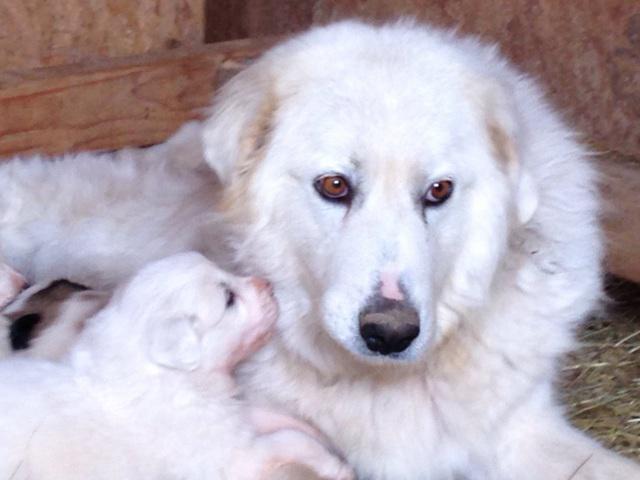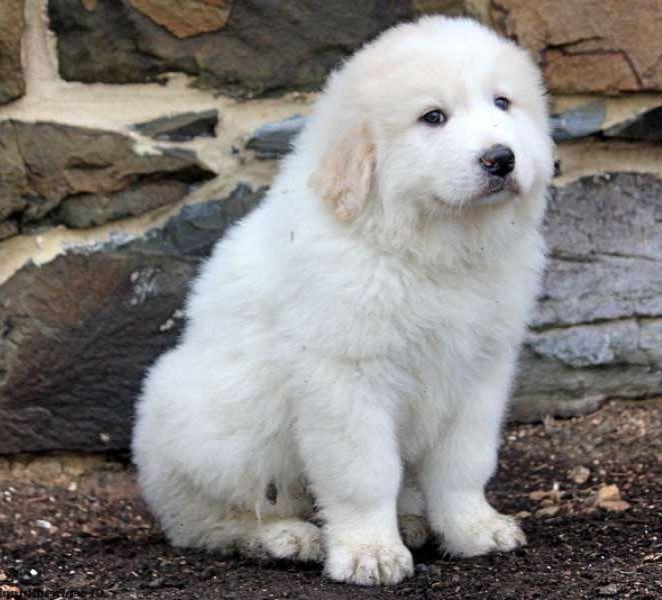The first image is the image on the left, the second image is the image on the right. For the images displayed, is the sentence "There are no more than two dogs." factually correct? Answer yes or no. No. The first image is the image on the left, the second image is the image on the right. For the images displayed, is the sentence "There is exactly one dog in each image." factually correct? Answer yes or no. No. 